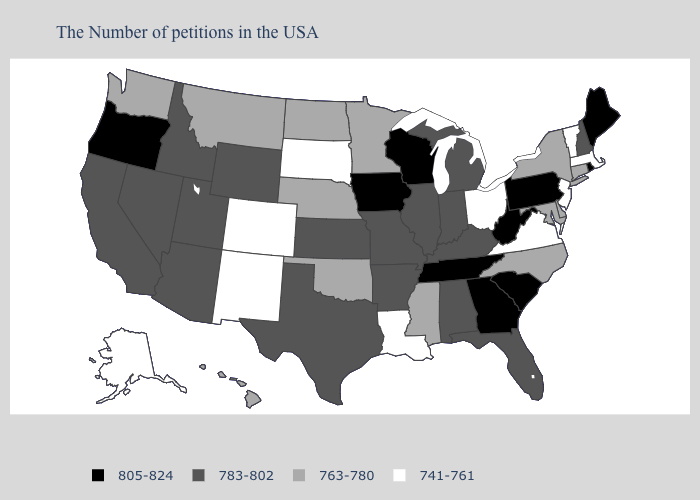Among the states that border Tennessee , which have the lowest value?
Keep it brief. Virginia. What is the lowest value in states that border Louisiana?
Quick response, please. 763-780. Does the map have missing data?
Be succinct. No. Name the states that have a value in the range 805-824?
Concise answer only. Maine, Rhode Island, Pennsylvania, South Carolina, West Virginia, Georgia, Tennessee, Wisconsin, Iowa, Oregon. Is the legend a continuous bar?
Give a very brief answer. No. What is the value of Hawaii?
Keep it brief. 763-780. What is the value of Montana?
Write a very short answer. 763-780. What is the lowest value in the South?
Answer briefly. 741-761. Name the states that have a value in the range 741-761?
Keep it brief. Massachusetts, Vermont, New Jersey, Virginia, Ohio, Louisiana, South Dakota, Colorado, New Mexico, Alaska. Among the states that border Tennessee , does Mississippi have the highest value?
Concise answer only. No. Among the states that border Connecticut , does New York have the lowest value?
Short answer required. No. Which states have the highest value in the USA?
Write a very short answer. Maine, Rhode Island, Pennsylvania, South Carolina, West Virginia, Georgia, Tennessee, Wisconsin, Iowa, Oregon. What is the value of Nebraska?
Answer briefly. 763-780. Does Rhode Island have the lowest value in the Northeast?
Keep it brief. No. Name the states that have a value in the range 783-802?
Give a very brief answer. New Hampshire, Florida, Michigan, Kentucky, Indiana, Alabama, Illinois, Missouri, Arkansas, Kansas, Texas, Wyoming, Utah, Arizona, Idaho, Nevada, California. 